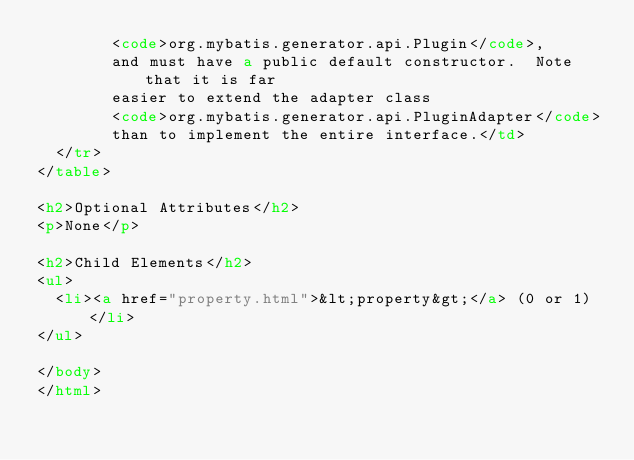<code> <loc_0><loc_0><loc_500><loc_500><_HTML_>        <code>org.mybatis.generator.api.Plugin</code>,
        and must have a public default constructor.  Note that it is far
        easier to extend the adapter class
        <code>org.mybatis.generator.api.PluginAdapter</code>
        than to implement the entire interface.</td>
  </tr>
</table>

<h2>Optional Attributes</h2>
<p>None</p>

<h2>Child Elements</h2>
<ul>
  <li><a href="property.html">&lt;property&gt;</a> (0 or 1)</li>
</ul>

</body>
</html>
</code> 